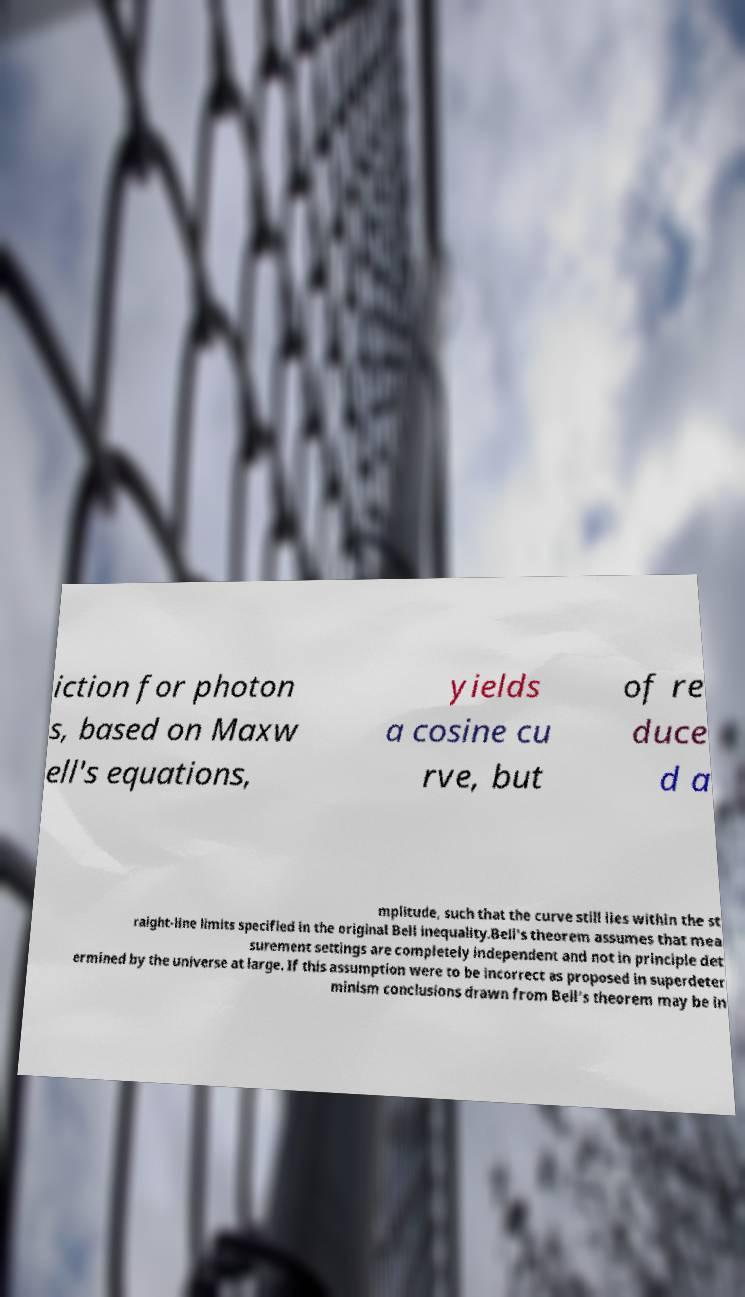Could you extract and type out the text from this image? iction for photon s, based on Maxw ell's equations, yields a cosine cu rve, but of re duce d a mplitude, such that the curve still lies within the st raight-line limits specified in the original Bell inequality.Bell's theorem assumes that mea surement settings are completely independent and not in principle det ermined by the universe at large. If this assumption were to be incorrect as proposed in superdeter minism conclusions drawn from Bell's theorem may be in 